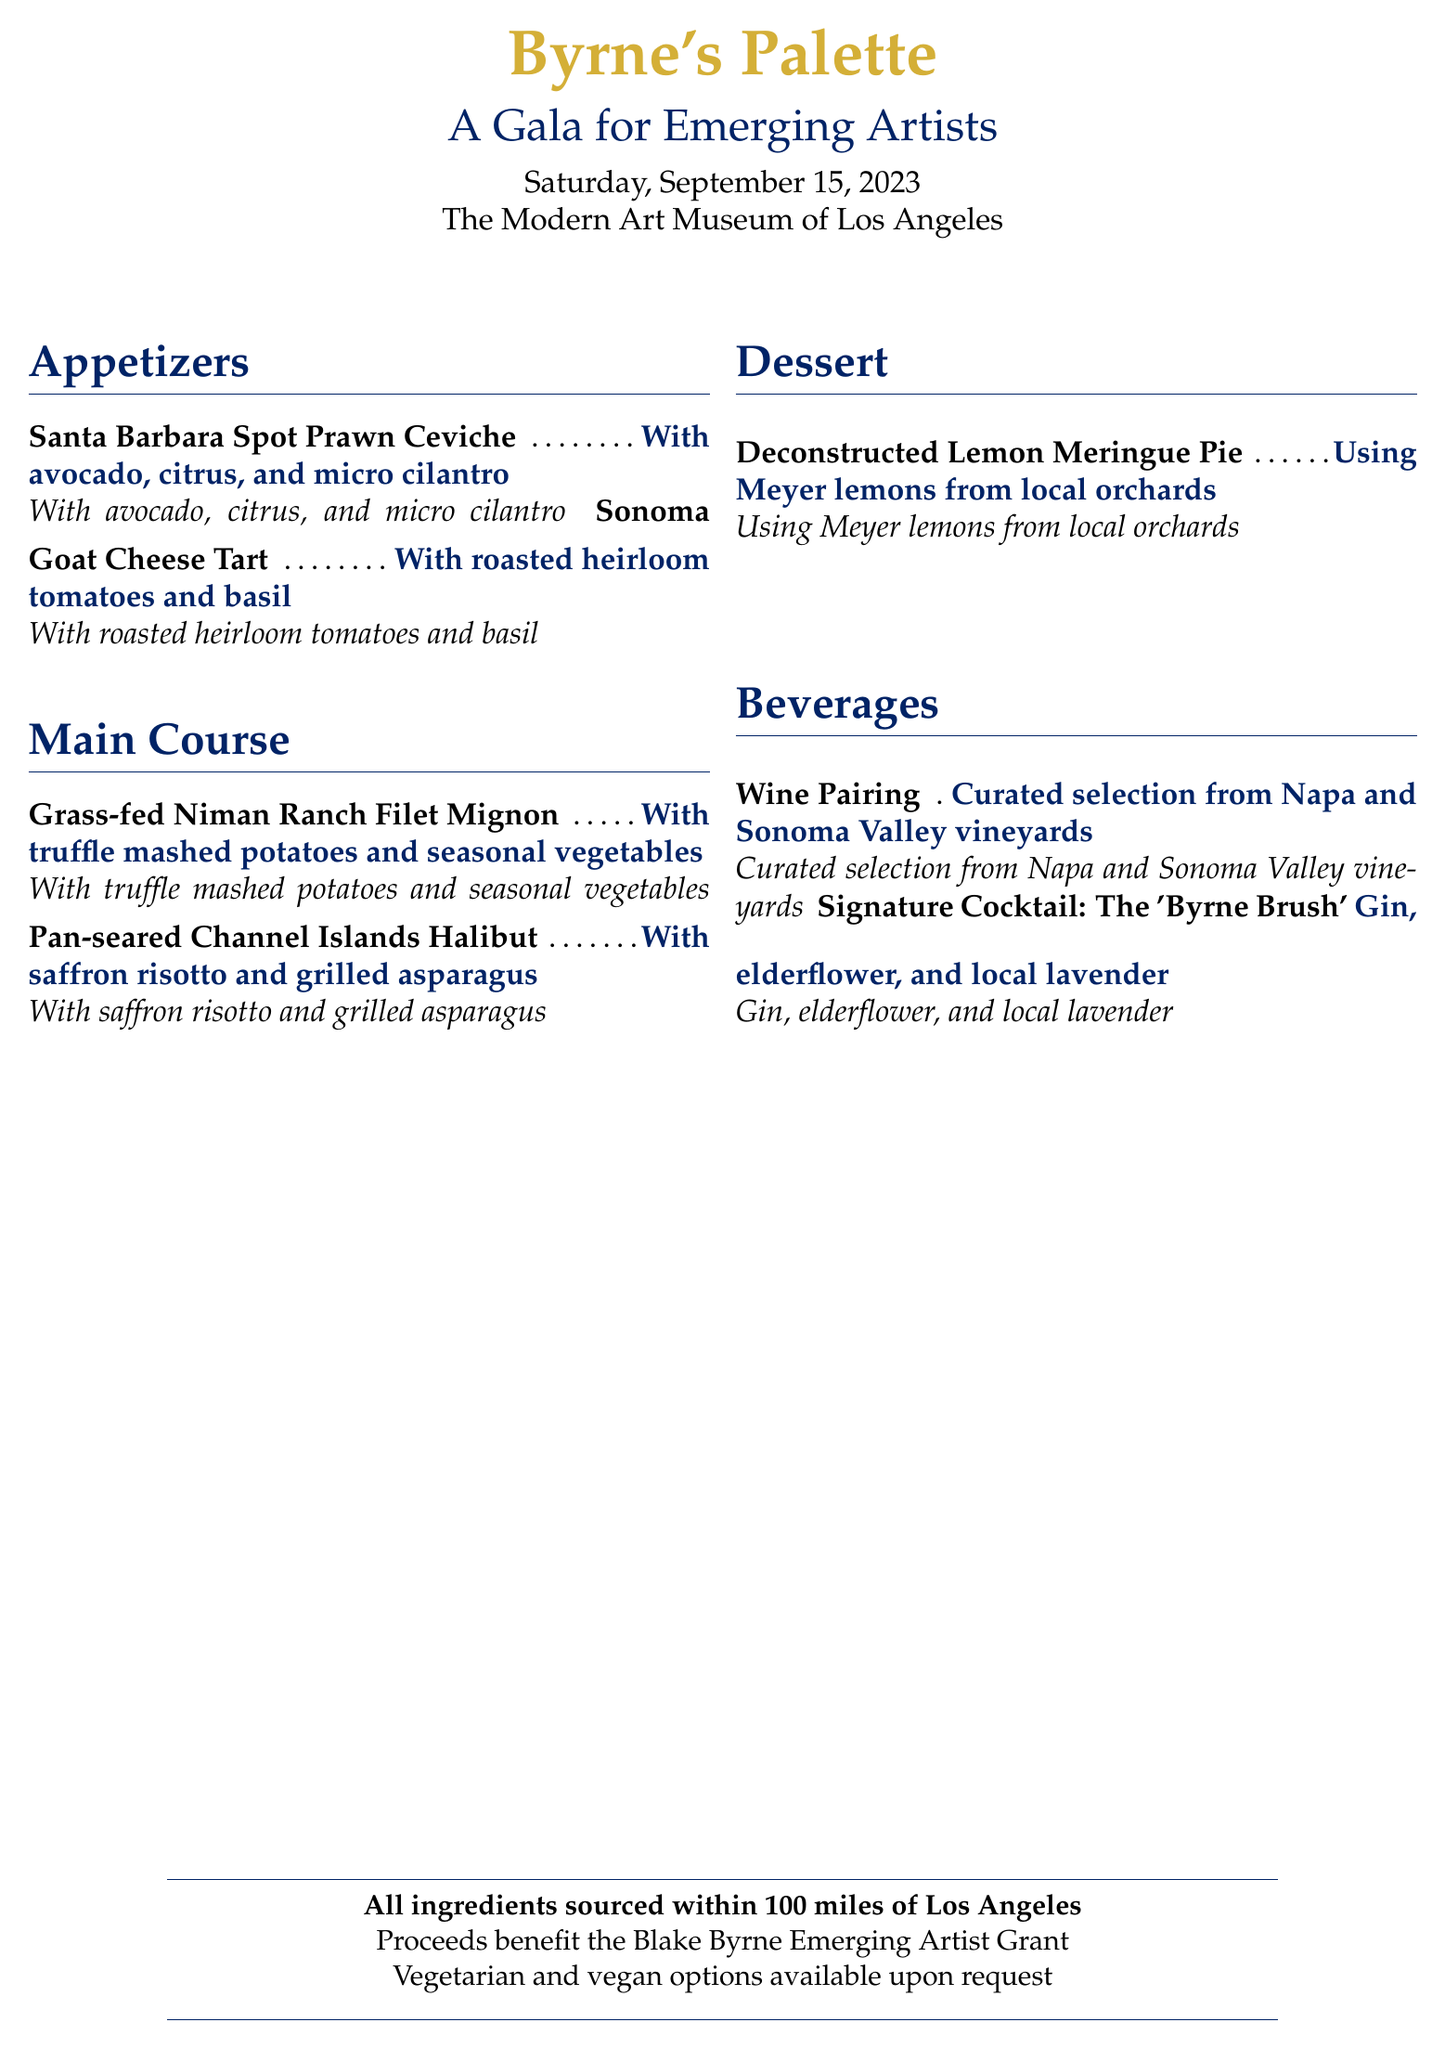What is the title of the event? The title of the event is prominently displayed at the top of the menu, showcasing its purpose and theme.
Answer: A Gala for Emerging Artists When is the gala dinner being held? The date of the event is mentioned under the title section, indicating when the gala will take place.
Answer: Saturday, September 15, 2023 Where is the gala dinner taking place? The location of the event is specified below the date, indicating where guests will gather for the gala.
Answer: The Modern Art Museum of Los Angeles What is one of the appetizers on the menu? The menu features a list of appetizers, and one can be found in the appetizers section.
Answer: Santa Barbara Spot Prawn Ceviche What type of fish is included in the main course? The main course section lists specific dishes, which include fish options.
Answer: Channel Islands Halibut What dessert is featured at the event? The dessert section of the menu lists the featured dessert, highlighting the culinary offerings.
Answer: Deconstructed Lemon Meringue Pie What is the signature cocktail named? The drinks section mentions a special cocktail and provides its title as part of the offerings.
Answer: The 'Byrne Brush' How far are the ingredients sourced from Los Angeles? The document specifies the sourcing radius for the ingredients used in the menu, emphasizing local sourcing.
Answer: 100 miles What does the proceeds benefit? The document indicates the purpose of the event, including who benefits from the proceeds of the dinner.
Answer: Blake Byrne Emerging Artist Grant 